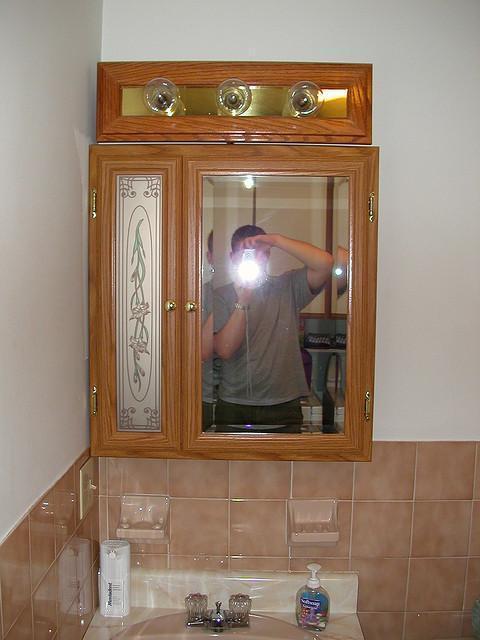How many bears are there?
Give a very brief answer. 0. 